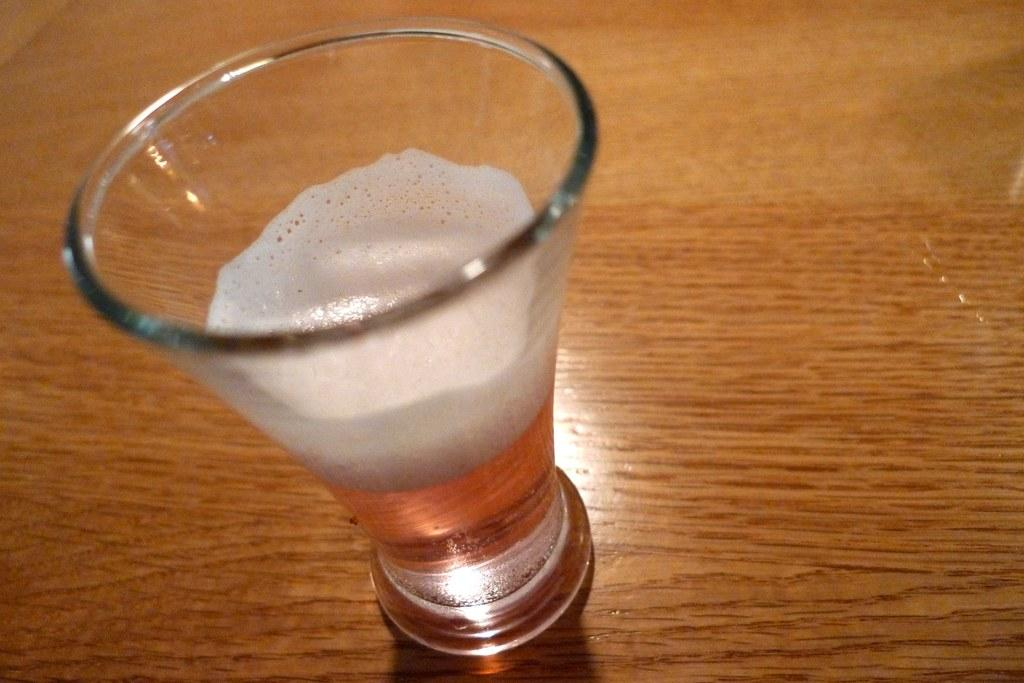What is in the glass that is visible in the image? There is liquid in the glass in the image. Where is the glass placed in the image? The glass is placed on a wooden surface. Can you see the parent and cub interacting with the glass in the image? There is no parent or cub present in the image; it only features a glass with liquid on a wooden surface. 